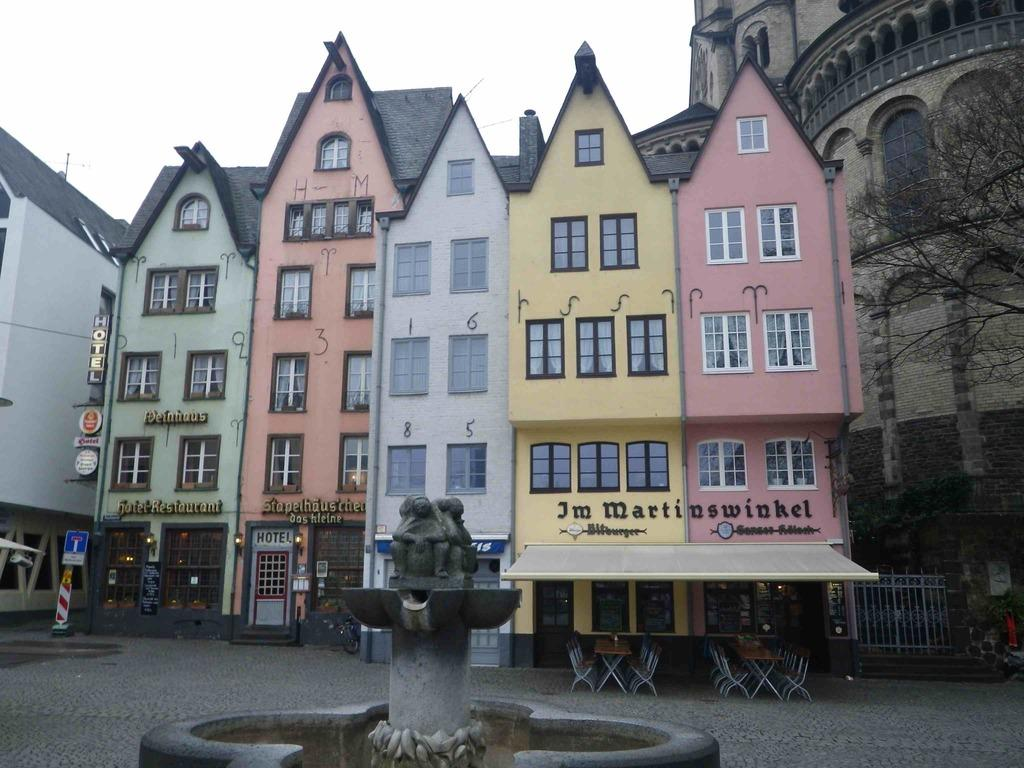What type of objects can be seen in the image that provide information or directions? There are sign boards in the image that provide information or directions. What is located in front of the buildings in the image? There is a statue in front of the buildings in the image. What type of advertisements or promotions can be seen in the image? There are hoardings in the image that display advertisements or promotions. What type of furniture is present in the image? There are chairs in the image. What type of natural elements can be seen in the image? There are trees in the image. What type of acoustics can be heard from the statue in the image? There is no information about the acoustics of the statue in the image, as it is a visual representation. What type of treatment is being provided to the trees in the image? There is no indication of any treatment being provided to the trees in the image; they appear to be natural and unaltered. 